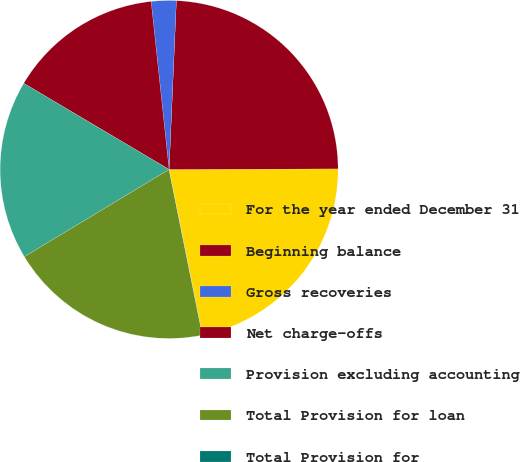Convert chart. <chart><loc_0><loc_0><loc_500><loc_500><pie_chart><fcel>For the year ended December 31<fcel>Beginning balance<fcel>Gross recoveries<fcel>Net charge-offs<fcel>Provision excluding accounting<fcel>Total Provision for loan<fcel>Total Provision for<nl><fcel>21.89%<fcel>24.26%<fcel>2.38%<fcel>14.79%<fcel>17.15%<fcel>19.52%<fcel>0.01%<nl></chart> 